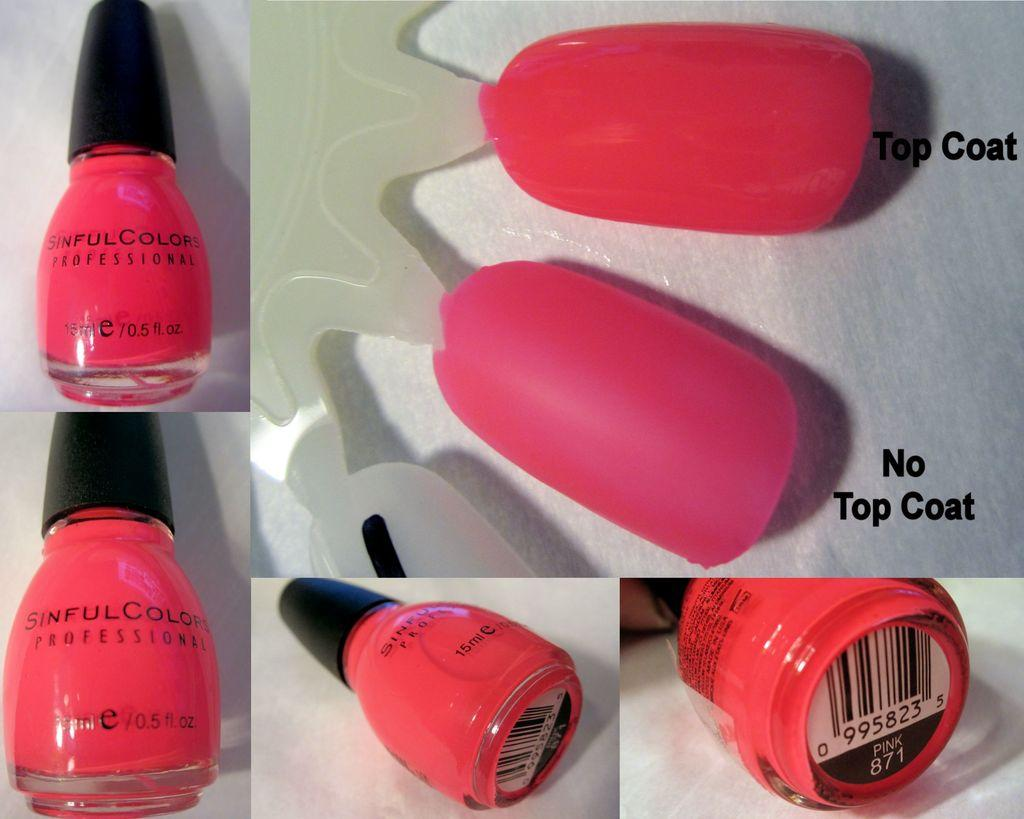What type of objects are present in the image? The image contains nails and nail polishes. Can you describe the appearance of the image? The image is in pink color. Has the image been altered in any way? Yes, the image is edited. How many pets can be seen in the image? There are no pets present in the image. What type of mouth is visible on the nail polish bottle in the image? There is no mouth visible in the image, as it features nails and nail polishes. 